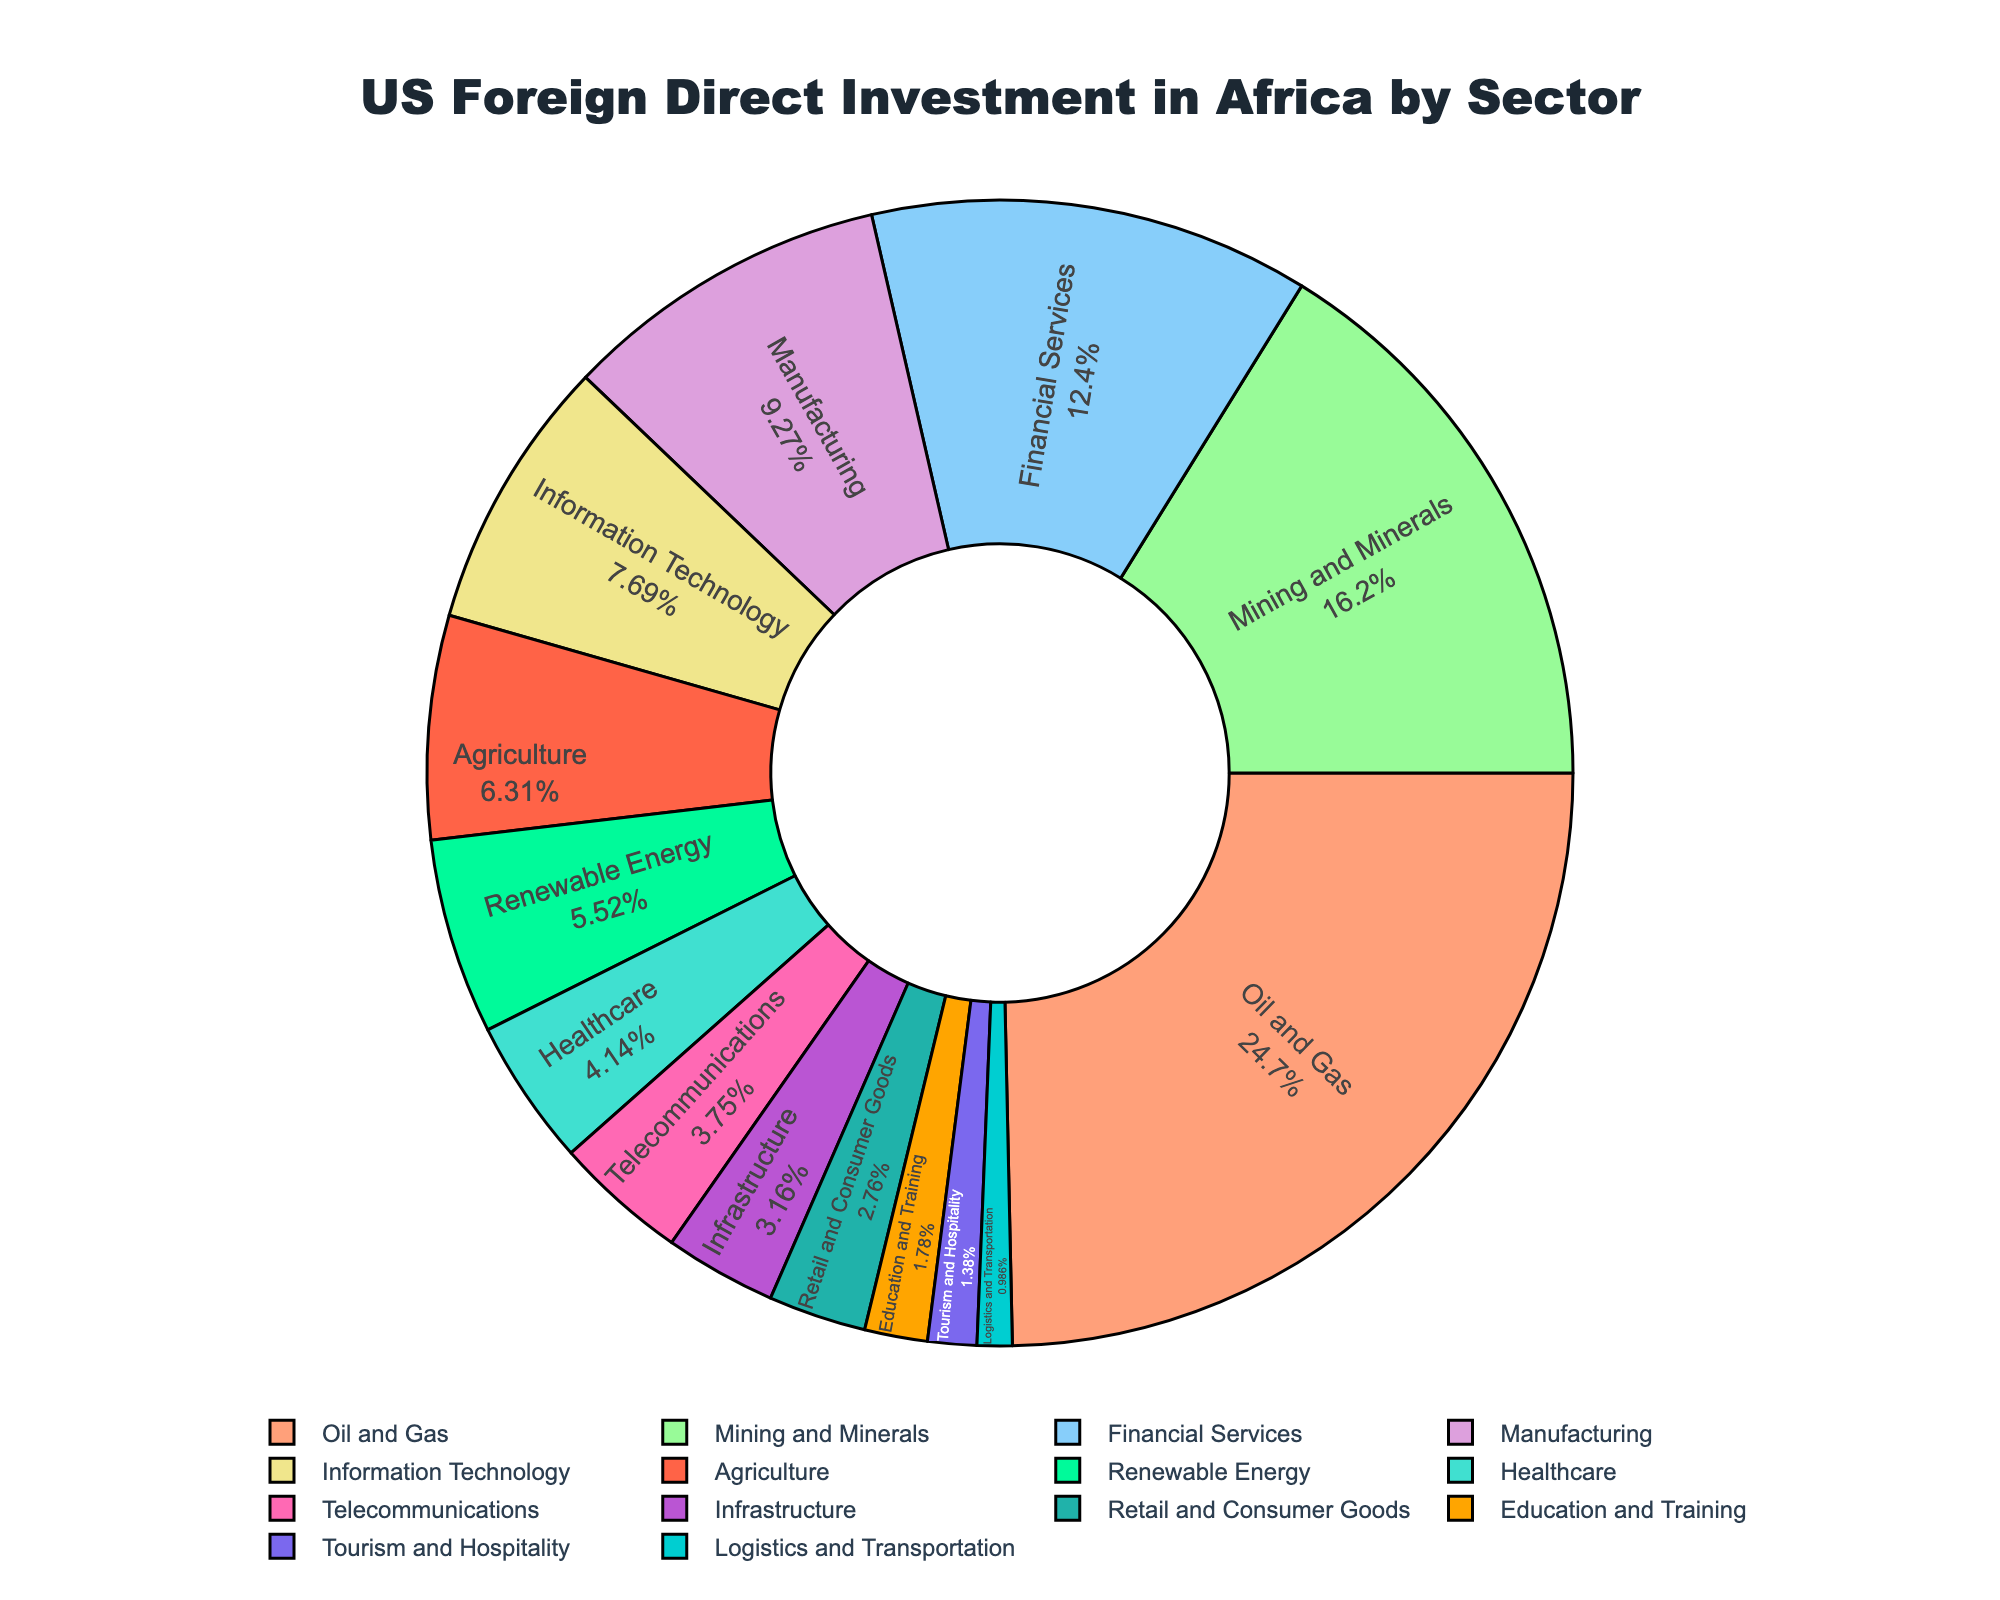What's the sector with the highest investment? To find the sector with the highest investment, look for the sector label on the largest slice of the pie chart. The largest slice is associated with "Oil and Gas" sector.
Answer: Oil and Gas What's the combined investment in the Manufacturing and Financial Services sectors? Locate the slices for "Manufacturing" and "Financial Services" sectors on the pie chart and note their investment values. The "Manufacturing" investment is 4700 USD Millions, and the "Financial Services" investment is 6300 USD Millions. Add these two values together: 4700 + 6300 = 11000 USD Millions.
Answer: 11000 USD Millions How much more investment is there in Oil and Gas compared to Healthcare? Identify the investment values for "Oil and Gas" and "Healthcare" sectors on the pie chart. The "Oil and Gas" investment is 12500 USD Millions, and the "Healthcare" investment is 2100 USD Millions. Subtract the Healthcare investment from the Oil and Gas investment: 12500 - 2100 = 10400 USD Millions.
Answer: 10400 USD Millions Which sector has a smaller investment: Telecommunications or Agriculture? Compare the sizes of the slices for "Telecommunications" and "Agriculture" sectors on the pie chart. The "Telecommunications" slice corresponds to 1900 USD Millions, while the "Agriculture" slice corresponds to 3200 USD Millions. Since 1900 < 3200, Telecommunications has a smaller investment.
Answer: Telecommunications What's the total investment in sectors other than Oil and Gas? Calculate the total investment by summing the investment values of all sectors excluding "Oil and Gas". Sum the values from all other sectors: 8200 + 6300 + 4700 + 3900 + 3200 + 2800 + 2100 + 1900 + 1600 + 1400 + 900 + 700 + 500 = 43200 USD Millions.
Answer: 43200 USD Millions What percentage of the total investment is in the Renewable Energy sector? Identify the investment value for the "Renewable Energy" sector, which is 2800 USD Millions. Next, find the total investment value, which is the sum of all sector investments: 12500 + 8200 + 6300 + 4700 + 3900 + 3200 + 2800 + 2100 + 1900 + 1600 + 1400 + 900 + 700 + 500 = 57700 USD Millions. Calculate the percentage: (2800 / 57700) * 100 ≈ 4.85%.
Answer: 4.85% Which sectors have investments less than 2000 USD Millions? Identify the sectors on the pie chart with investments less than 2000 USD Millions. These sectors are Telecommunications (1900), Infrastructure (1600), Retail and Consumer Goods (1400), Education and Training (900), Tourism and Hospitality (700), and Logistics and Transportation (500).
Answer: Telecommunications, Infrastructure, Retail and Consumer Goods, Education and Training, Tourism and Hospitality, Logistics and Transportation How does the investment in Manufacturing compare to Information Technology in terms of size in the pie chart? Locate the slices representative of "Manufacturing" and "Information Technology" sectors. The "Manufacturing" sector has an investment of 4700 USD Millions, while the "Information Technology" sector has an investment of 3900 USD Millions. Since 4700 > 3900, the "Manufacturing" sector slice is larger than the "Information Technology" sector slice.
Answer: Manufacturing is larger Which sectors together make up more than 50% of the total investment? Determine the combined percentage of the leading sectors. The largest sectors are Oil and Gas (12500), Mining and Minerals (8200), and Financial Services (6300). Calculate their percentage contributions to the total: (12500 / 57700) + (8200 / 57700) + (6300 / 57700) = 0.216 + 0.142 + 0.109 ≈ 46.7%. Adding Manufacturing (4700): (4700 / 57700) ≈ 8.1%, total: 46.7% + 8.1% ≈ 54.8%. Thus, the sectors Oil and Gas, Mining and Minerals, Financial Services, and Manufacturing together make up more than 50%.
Answer: Oil and Gas, Mining and Minerals, Financial Services, Manufacturing What are the three sectors with the lowest investments and their respective values? Identify the smallest three slices on the pie chart. These sectors are Logistics and Transportation (500 USD Millions), Tourism and Hospitality (700 USD Millions), and Education and Training (900 USD Millions).
Answer: Logistics and Transportation (500), Tourism and Hospitality (700), Education and Training (900) 